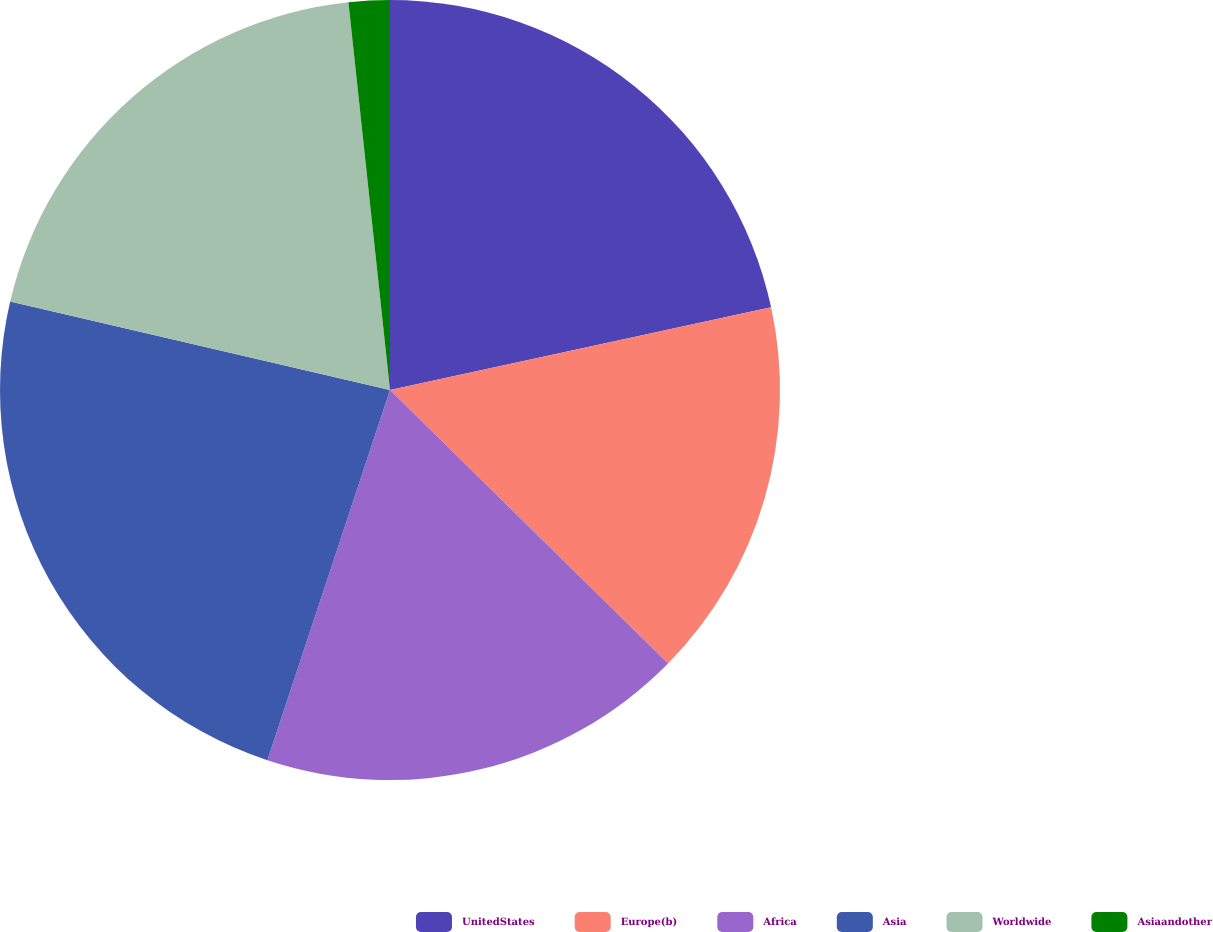Convert chart. <chart><loc_0><loc_0><loc_500><loc_500><pie_chart><fcel>UnitedStates<fcel>Europe(b)<fcel>Africa<fcel>Asia<fcel>Worldwide<fcel>Asiaandother<nl><fcel>21.6%<fcel>15.77%<fcel>17.72%<fcel>23.55%<fcel>19.66%<fcel>1.7%<nl></chart> 